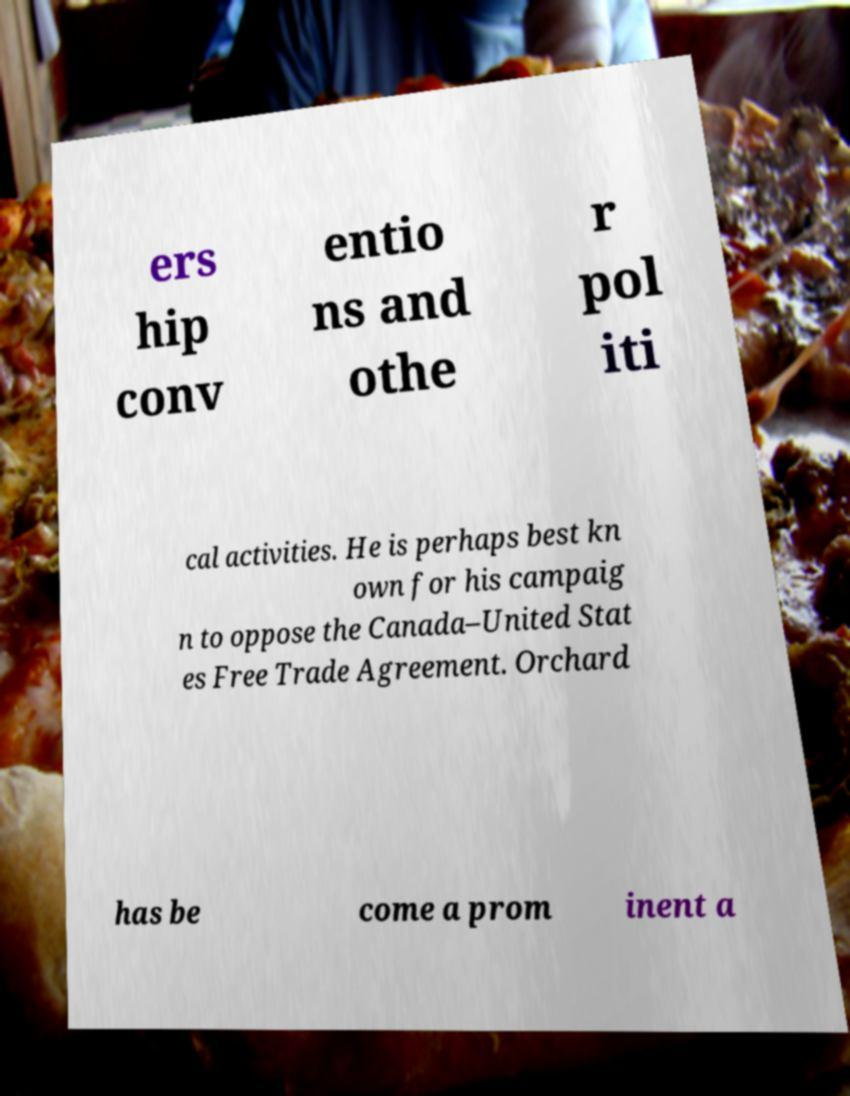Can you read and provide the text displayed in the image?This photo seems to have some interesting text. Can you extract and type it out for me? ers hip conv entio ns and othe r pol iti cal activities. He is perhaps best kn own for his campaig n to oppose the Canada–United Stat es Free Trade Agreement. Orchard has be come a prom inent a 